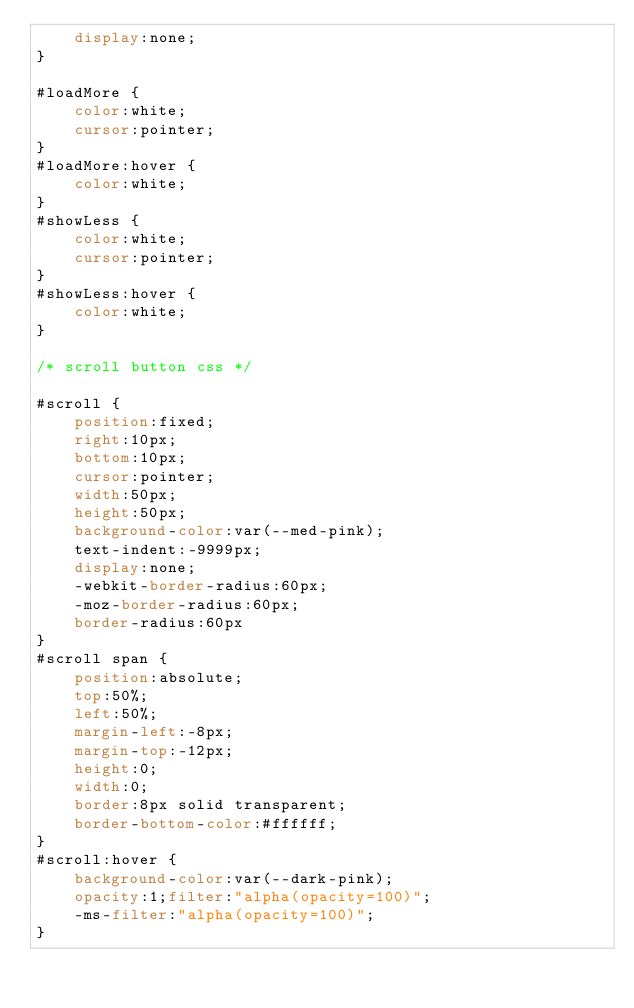<code> <loc_0><loc_0><loc_500><loc_500><_CSS_>    display:none;
}

#loadMore {
    color:white;
    cursor:pointer;
}
#loadMore:hover {
    color:white;
}
#showLess {
    color:white;
    cursor:pointer;
}
#showLess:hover {
    color:white;
}

/* scroll button css */

#scroll {
    position:fixed;
    right:10px;
    bottom:10px;
    cursor:pointer;
    width:50px;
    height:50px;
    background-color:var(--med-pink);
    text-indent:-9999px;
    display:none;
    -webkit-border-radius:60px;
    -moz-border-radius:60px;
    border-radius:60px
}
#scroll span {
    position:absolute;
    top:50%;
    left:50%;
    margin-left:-8px;
    margin-top:-12px;
    height:0;
    width:0;
    border:8px solid transparent;
    border-bottom-color:#ffffff;
}
#scroll:hover {
    background-color:var(--dark-pink);
    opacity:1;filter:"alpha(opacity=100)";
    -ms-filter:"alpha(opacity=100)";
}


</code> 